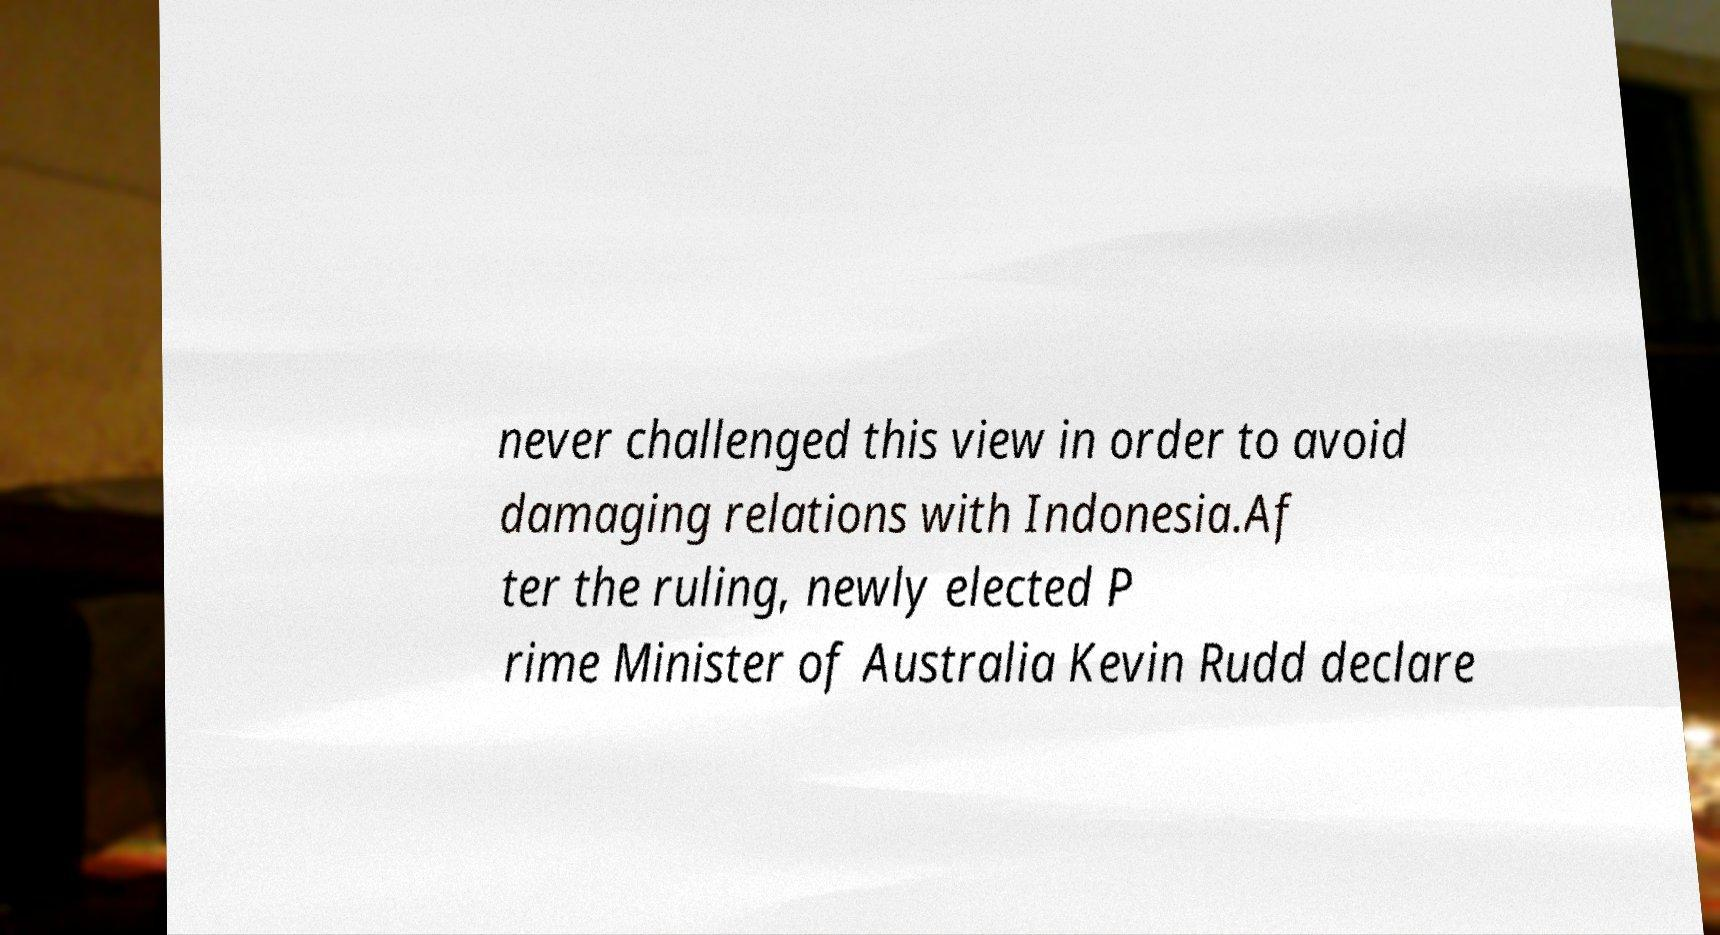I need the written content from this picture converted into text. Can you do that? never challenged this view in order to avoid damaging relations with Indonesia.Af ter the ruling, newly elected P rime Minister of Australia Kevin Rudd declare 